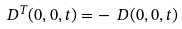Convert formula to latex. <formula><loc_0><loc_0><loc_500><loc_500>\ D ^ { T } ( 0 , 0 , t ) = - \ D ( 0 , 0 , t )</formula> 